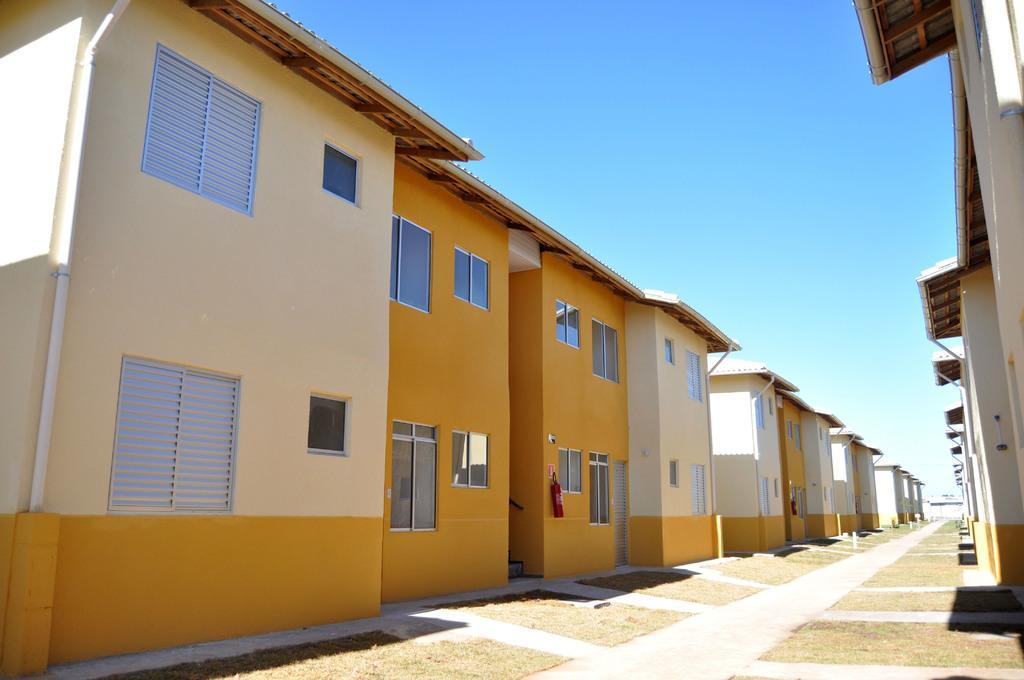Describe this image in one or two sentences. In this image I can see number of buildings and a path. I can also see a fire extinguisher on a wall of a building. In the background I can see clear sky. 